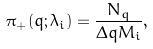Convert formula to latex. <formula><loc_0><loc_0><loc_500><loc_500>\pi _ { + } ( q ; \lambda _ { i } ) = \frac { N _ { q } } { \Delta q M _ { i } } ,</formula> 